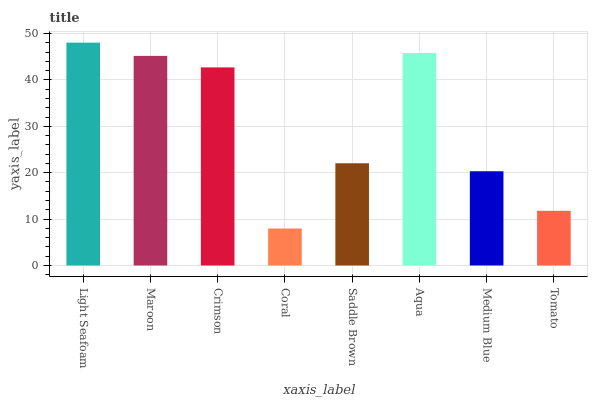Is Coral the minimum?
Answer yes or no. Yes. Is Light Seafoam the maximum?
Answer yes or no. Yes. Is Maroon the minimum?
Answer yes or no. No. Is Maroon the maximum?
Answer yes or no. No. Is Light Seafoam greater than Maroon?
Answer yes or no. Yes. Is Maroon less than Light Seafoam?
Answer yes or no. Yes. Is Maroon greater than Light Seafoam?
Answer yes or no. No. Is Light Seafoam less than Maroon?
Answer yes or no. No. Is Crimson the high median?
Answer yes or no. Yes. Is Saddle Brown the low median?
Answer yes or no. Yes. Is Tomato the high median?
Answer yes or no. No. Is Coral the low median?
Answer yes or no. No. 